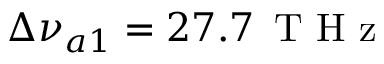<formula> <loc_0><loc_0><loc_500><loc_500>\Delta \nu _ { a 1 } = 2 7 . 7 \, T H z</formula> 